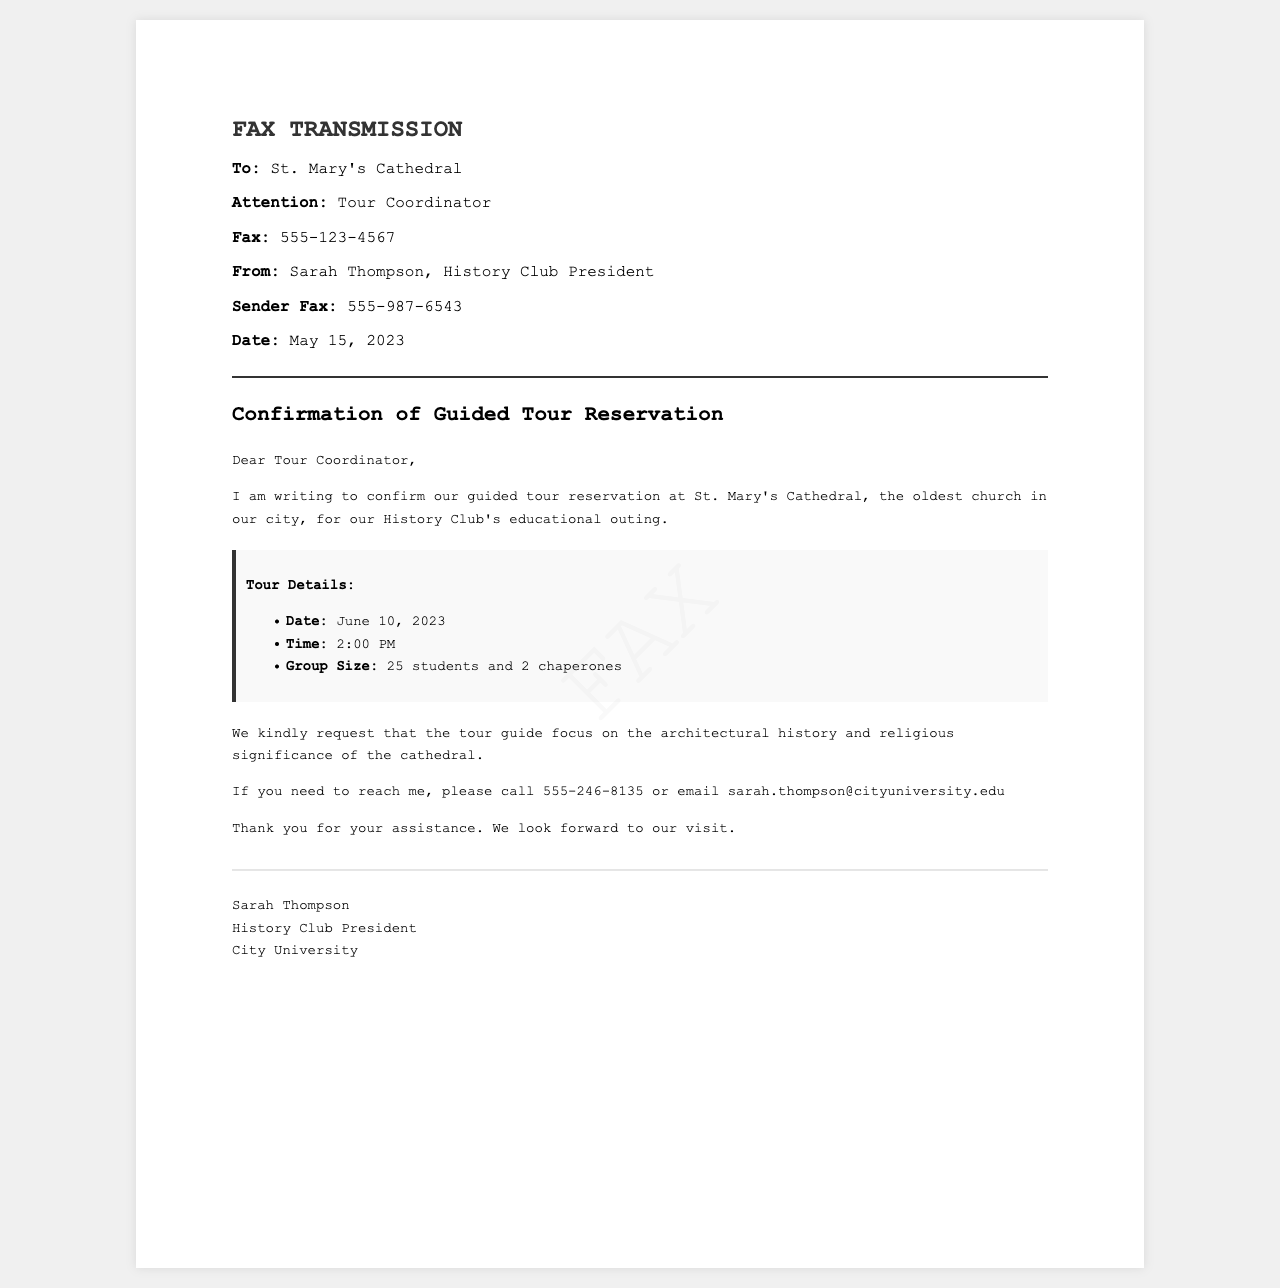What is the name of the church? The church mentioned in the document is St. Mary's Cathedral.
Answer: St. Mary's Cathedral What is the date of the guided tour? The guided tour is confirmed for June 10, 2023.
Answer: June 10, 2023 How many students are in the group size? The group size includes 25 students.
Answer: 25 students What time is the tour scheduled to start? The tour is scheduled to start at 2:00 PM.
Answer: 2:00 PM Who is the sender of the fax? The sender of the fax is Sarah Thompson, the History Club President.
Answer: Sarah Thompson What is the total number of people in the group? The total number of people includes 25 students and 2 chaperones, which totals 27.
Answer: 27 What is the sender's email address? The email address of the sender is sarah.thompson@cityuniversity.edu.
Answer: sarah.thompson@cityuniversity.edu What should the tour guide focus on during the tour? The tour guide should focus on the architectural history and religious significance.
Answer: Architectural history and religious significance What is the fax number for St. Mary's Cathedral? The fax number provided for St. Mary's Cathedral is 555-123-4567.
Answer: 555-123-4567 